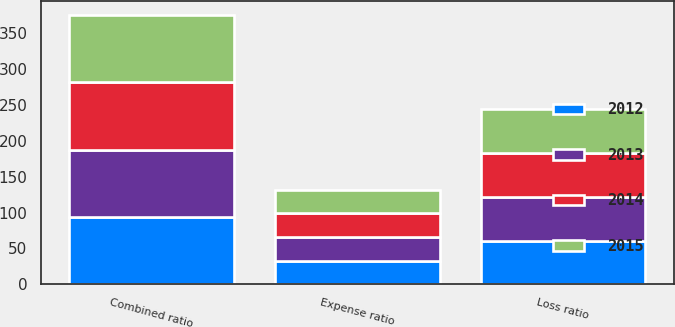Convert chart to OTSL. <chart><loc_0><loc_0><loc_500><loc_500><stacked_bar_chart><ecel><fcel>Loss ratio<fcel>Expense ratio<fcel>Combined ratio<nl><fcel>2015<fcel>61<fcel>32.6<fcel>93.6<nl><fcel>2012<fcel>60.8<fcel>32.6<fcel>93.4<nl><fcel>2013<fcel>60.6<fcel>32.9<fcel>93.5<nl><fcel>2014<fcel>61<fcel>33.7<fcel>94.7<nl></chart> 